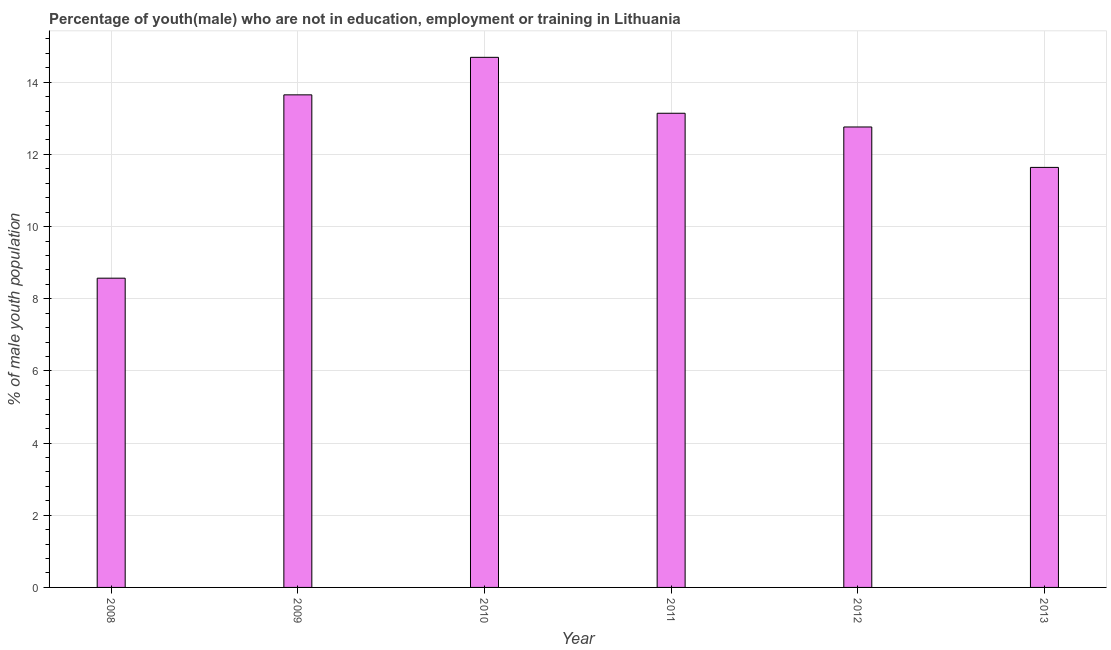Does the graph contain any zero values?
Your answer should be compact. No. What is the title of the graph?
Offer a very short reply. Percentage of youth(male) who are not in education, employment or training in Lithuania. What is the label or title of the X-axis?
Keep it short and to the point. Year. What is the label or title of the Y-axis?
Ensure brevity in your answer.  % of male youth population. What is the unemployed male youth population in 2008?
Provide a succinct answer. 8.57. Across all years, what is the maximum unemployed male youth population?
Keep it short and to the point. 14.69. Across all years, what is the minimum unemployed male youth population?
Give a very brief answer. 8.57. In which year was the unemployed male youth population maximum?
Ensure brevity in your answer.  2010. In which year was the unemployed male youth population minimum?
Ensure brevity in your answer.  2008. What is the sum of the unemployed male youth population?
Provide a succinct answer. 74.45. What is the difference between the unemployed male youth population in 2011 and 2013?
Ensure brevity in your answer.  1.5. What is the average unemployed male youth population per year?
Provide a succinct answer. 12.41. What is the median unemployed male youth population?
Offer a very short reply. 12.95. Do a majority of the years between 2010 and 2012 (inclusive) have unemployed male youth population greater than 2.8 %?
Keep it short and to the point. Yes. Is the unemployed male youth population in 2008 less than that in 2011?
Your response must be concise. Yes. Is the difference between the unemployed male youth population in 2009 and 2013 greater than the difference between any two years?
Your answer should be very brief. No. What is the difference between the highest and the second highest unemployed male youth population?
Offer a very short reply. 1.04. Is the sum of the unemployed male youth population in 2010 and 2011 greater than the maximum unemployed male youth population across all years?
Provide a succinct answer. Yes. What is the difference between the highest and the lowest unemployed male youth population?
Provide a succinct answer. 6.12. In how many years, is the unemployed male youth population greater than the average unemployed male youth population taken over all years?
Your response must be concise. 4. Are all the bars in the graph horizontal?
Your answer should be very brief. No. How many years are there in the graph?
Offer a terse response. 6. What is the % of male youth population in 2008?
Provide a short and direct response. 8.57. What is the % of male youth population in 2009?
Your answer should be very brief. 13.65. What is the % of male youth population in 2010?
Provide a succinct answer. 14.69. What is the % of male youth population in 2011?
Provide a succinct answer. 13.14. What is the % of male youth population in 2012?
Your answer should be very brief. 12.76. What is the % of male youth population of 2013?
Provide a succinct answer. 11.64. What is the difference between the % of male youth population in 2008 and 2009?
Offer a very short reply. -5.08. What is the difference between the % of male youth population in 2008 and 2010?
Offer a terse response. -6.12. What is the difference between the % of male youth population in 2008 and 2011?
Make the answer very short. -4.57. What is the difference between the % of male youth population in 2008 and 2012?
Provide a short and direct response. -4.19. What is the difference between the % of male youth population in 2008 and 2013?
Give a very brief answer. -3.07. What is the difference between the % of male youth population in 2009 and 2010?
Your response must be concise. -1.04. What is the difference between the % of male youth population in 2009 and 2011?
Your answer should be very brief. 0.51. What is the difference between the % of male youth population in 2009 and 2012?
Make the answer very short. 0.89. What is the difference between the % of male youth population in 2009 and 2013?
Offer a very short reply. 2.01. What is the difference between the % of male youth population in 2010 and 2011?
Offer a terse response. 1.55. What is the difference between the % of male youth population in 2010 and 2012?
Offer a terse response. 1.93. What is the difference between the % of male youth population in 2010 and 2013?
Keep it short and to the point. 3.05. What is the difference between the % of male youth population in 2011 and 2012?
Offer a terse response. 0.38. What is the difference between the % of male youth population in 2012 and 2013?
Your answer should be compact. 1.12. What is the ratio of the % of male youth population in 2008 to that in 2009?
Ensure brevity in your answer.  0.63. What is the ratio of the % of male youth population in 2008 to that in 2010?
Offer a terse response. 0.58. What is the ratio of the % of male youth population in 2008 to that in 2011?
Offer a terse response. 0.65. What is the ratio of the % of male youth population in 2008 to that in 2012?
Ensure brevity in your answer.  0.67. What is the ratio of the % of male youth population in 2008 to that in 2013?
Provide a short and direct response. 0.74. What is the ratio of the % of male youth population in 2009 to that in 2010?
Offer a very short reply. 0.93. What is the ratio of the % of male youth population in 2009 to that in 2011?
Your answer should be very brief. 1.04. What is the ratio of the % of male youth population in 2009 to that in 2012?
Provide a succinct answer. 1.07. What is the ratio of the % of male youth population in 2009 to that in 2013?
Offer a terse response. 1.17. What is the ratio of the % of male youth population in 2010 to that in 2011?
Provide a succinct answer. 1.12. What is the ratio of the % of male youth population in 2010 to that in 2012?
Ensure brevity in your answer.  1.15. What is the ratio of the % of male youth population in 2010 to that in 2013?
Offer a terse response. 1.26. What is the ratio of the % of male youth population in 2011 to that in 2013?
Make the answer very short. 1.13. What is the ratio of the % of male youth population in 2012 to that in 2013?
Provide a succinct answer. 1.1. 